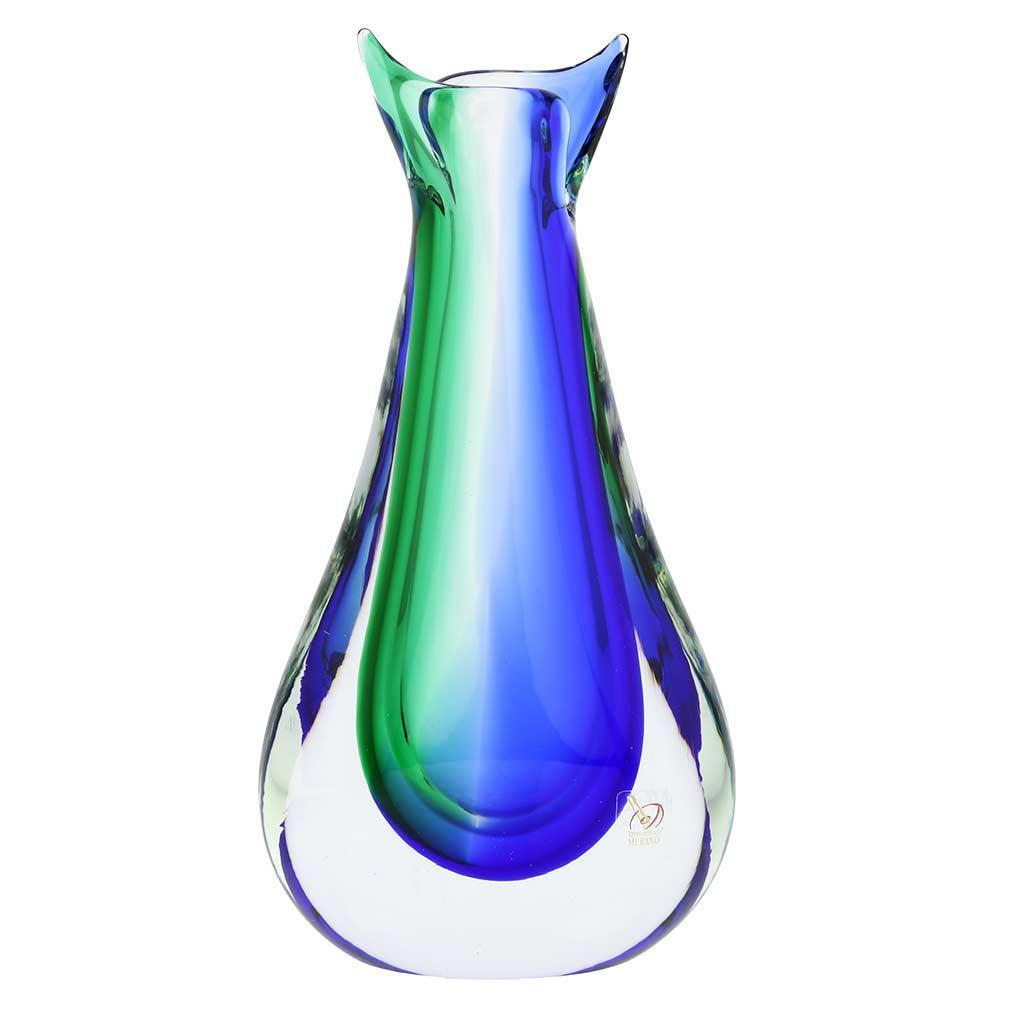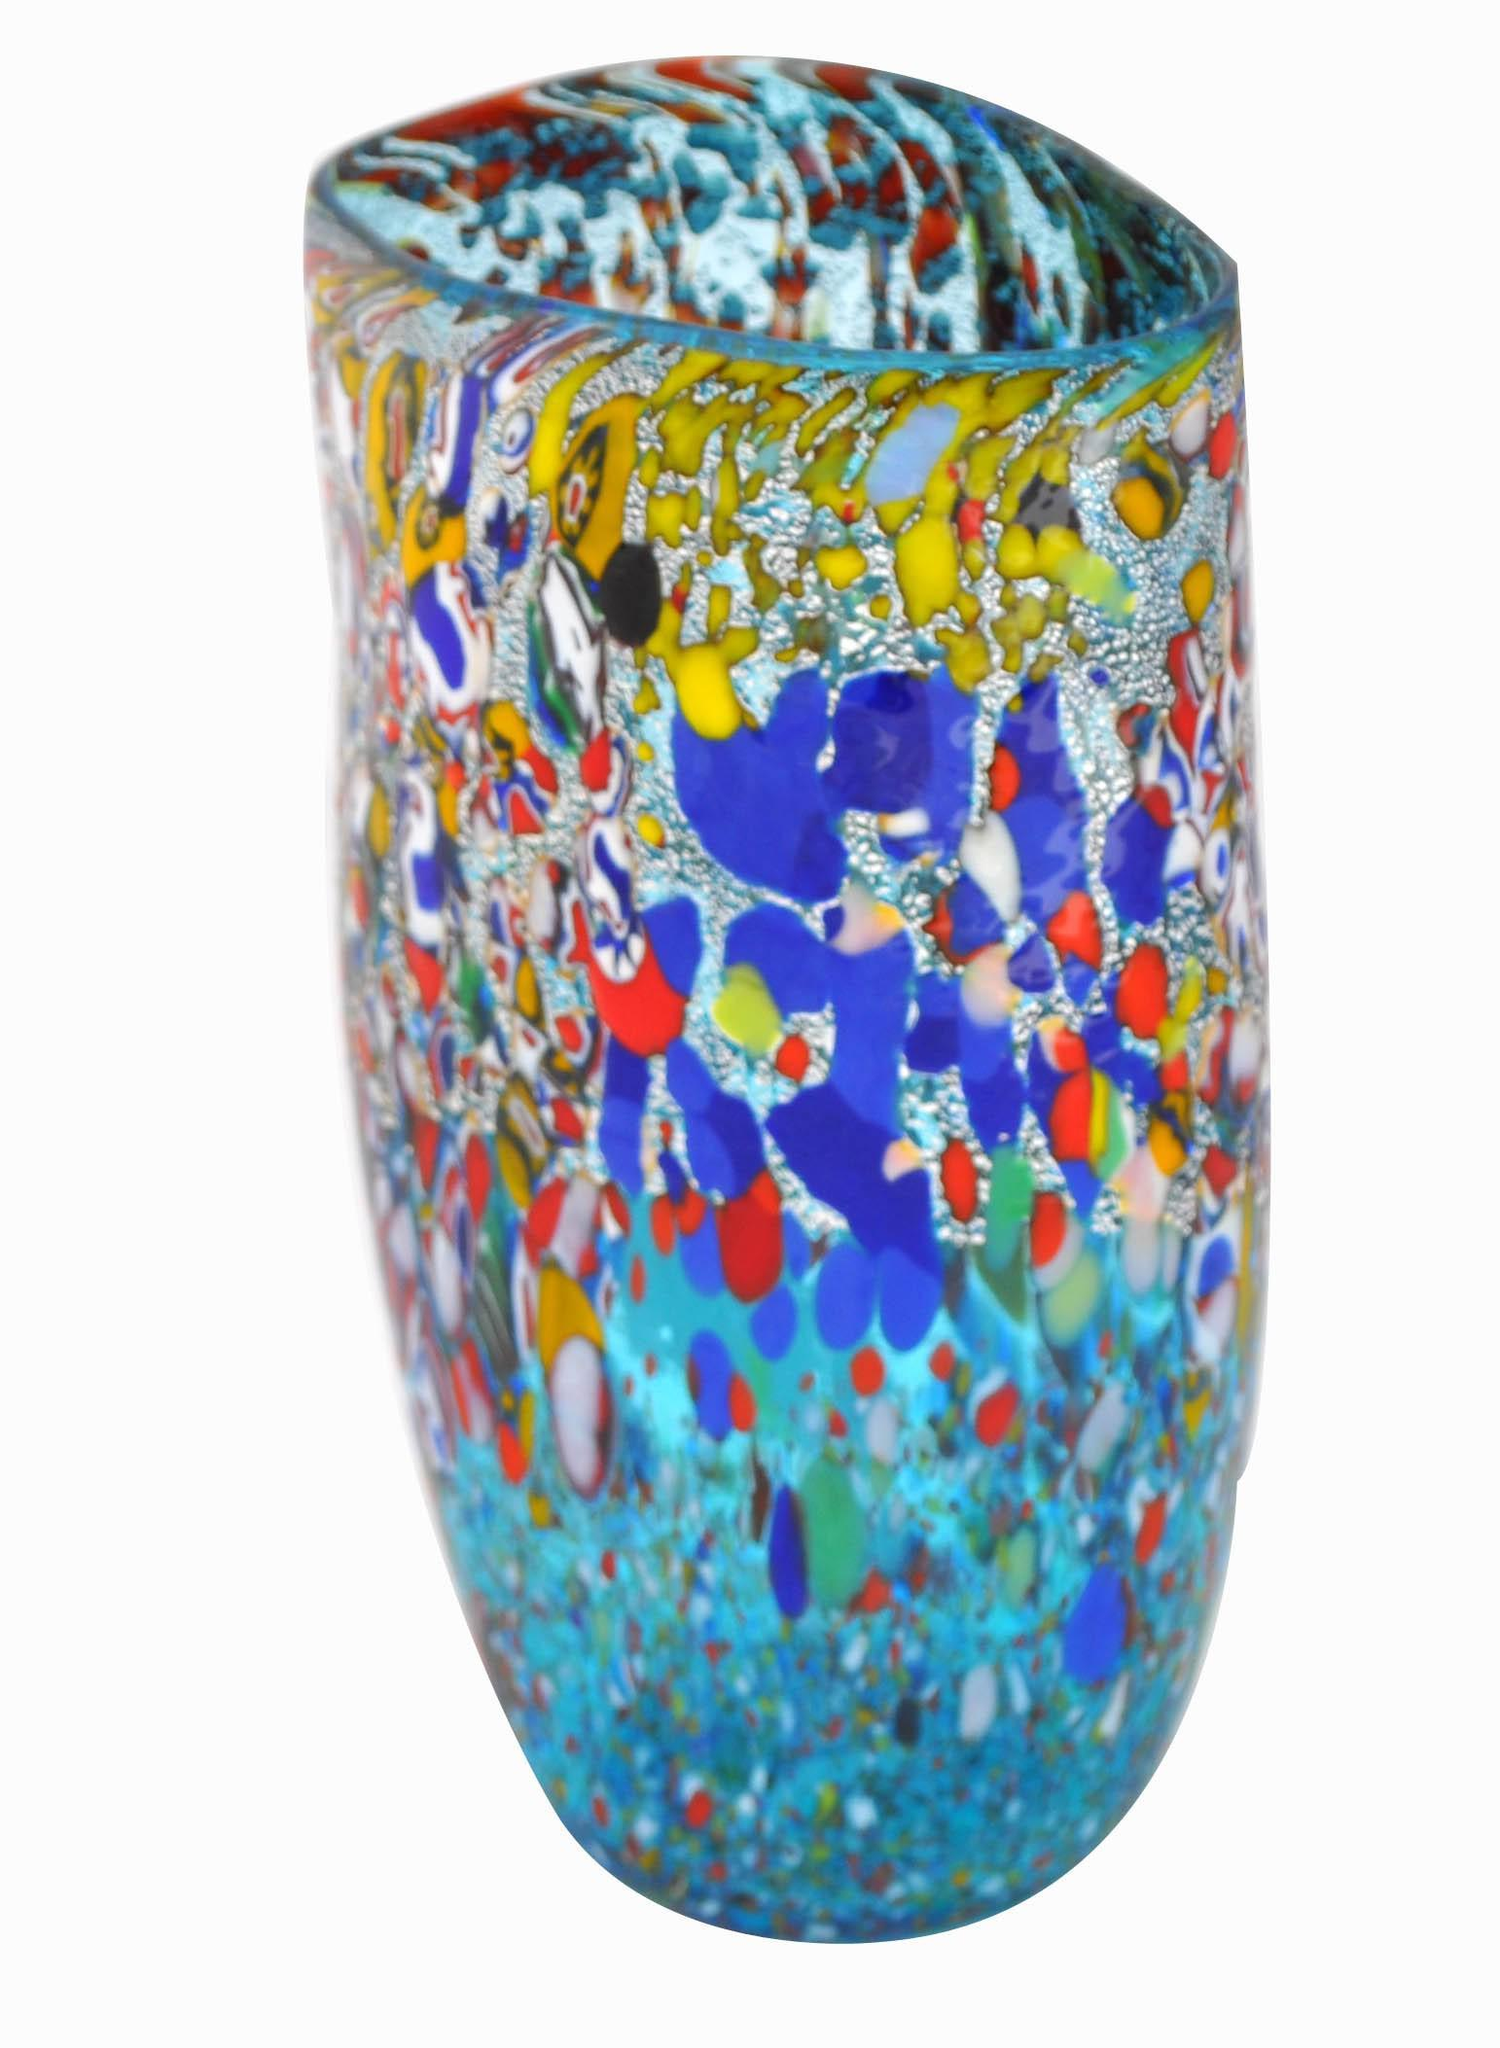The first image is the image on the left, the second image is the image on the right. Examine the images to the left and right. Is the description "The vase in the right image is bluish-green, with no other bright colors on it." accurate? Answer yes or no. No. The first image is the image on the left, the second image is the image on the right. Evaluate the accuracy of this statement regarding the images: "The vase on the right is a green color.". Is it true? Answer yes or no. No. 